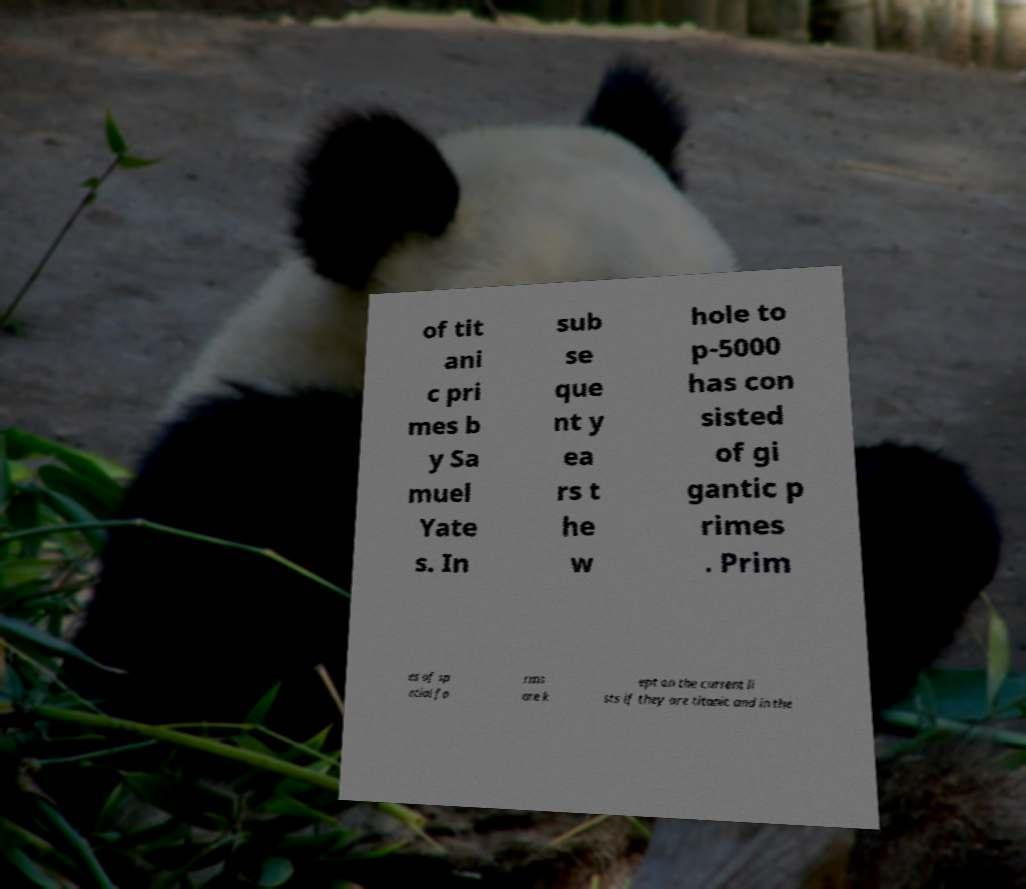Could you assist in decoding the text presented in this image and type it out clearly? of tit ani c pri mes b y Sa muel Yate s. In sub se que nt y ea rs t he w hole to p-5000 has con sisted of gi gantic p rimes . Prim es of sp ecial fo rms are k ept on the current li sts if they are titanic and in the 